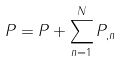<formula> <loc_0><loc_0><loc_500><loc_500>P = P + \sum ^ { N } _ { n = 1 } P _ { , n }</formula> 